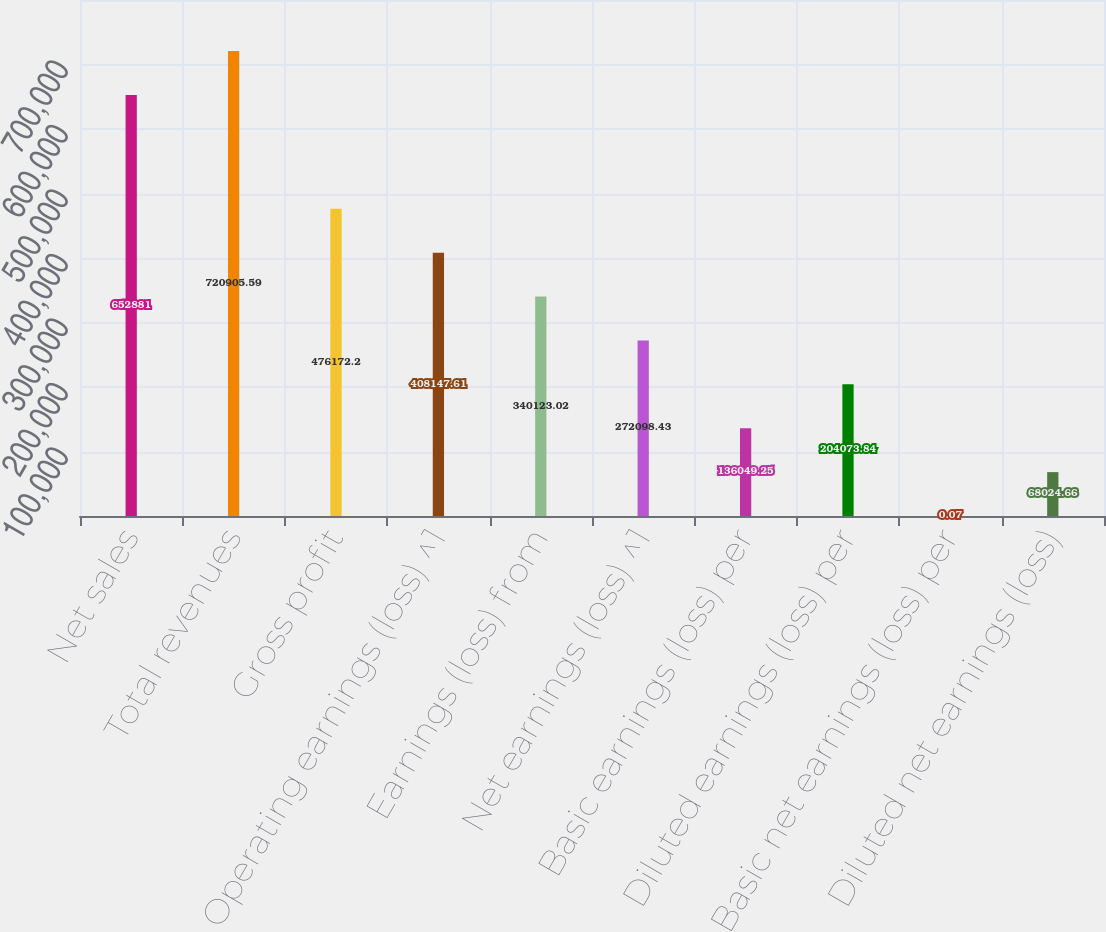Convert chart. <chart><loc_0><loc_0><loc_500><loc_500><bar_chart><fcel>Net sales<fcel>Total revenues<fcel>Gross profit<fcel>Operating earnings (loss) ^1<fcel>Earnings (loss) from<fcel>Net earnings (loss) ^1<fcel>Basic earnings (loss) per<fcel>Diluted earnings (loss) per<fcel>Basic net earnings (loss) per<fcel>Diluted net earnings (loss)<nl><fcel>652881<fcel>720906<fcel>476172<fcel>408148<fcel>340123<fcel>272098<fcel>136049<fcel>204074<fcel>0.07<fcel>68024.7<nl></chart> 